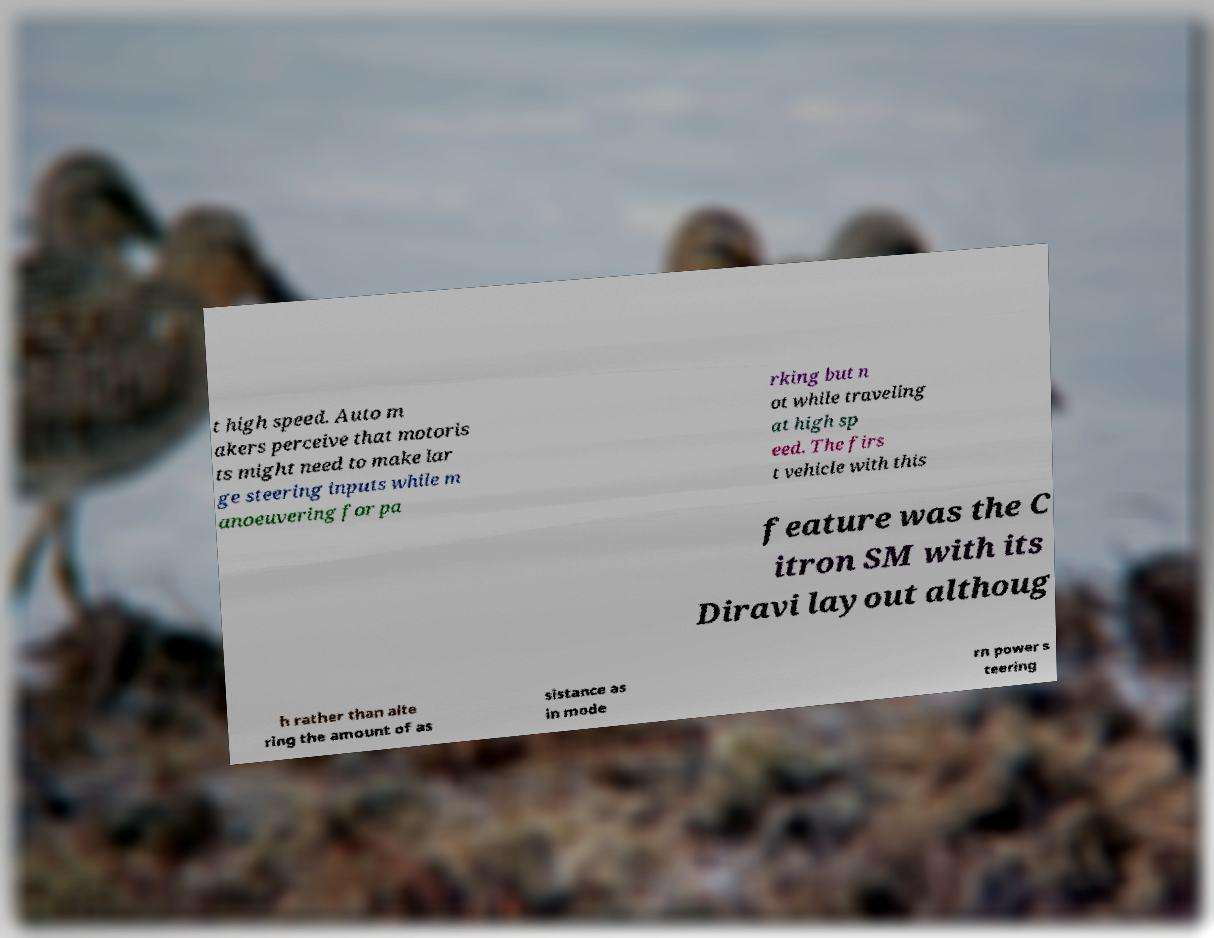Can you accurately transcribe the text from the provided image for me? t high speed. Auto m akers perceive that motoris ts might need to make lar ge steering inputs while m anoeuvering for pa rking but n ot while traveling at high sp eed. The firs t vehicle with this feature was the C itron SM with its Diravi layout althoug h rather than alte ring the amount of as sistance as in mode rn power s teering 